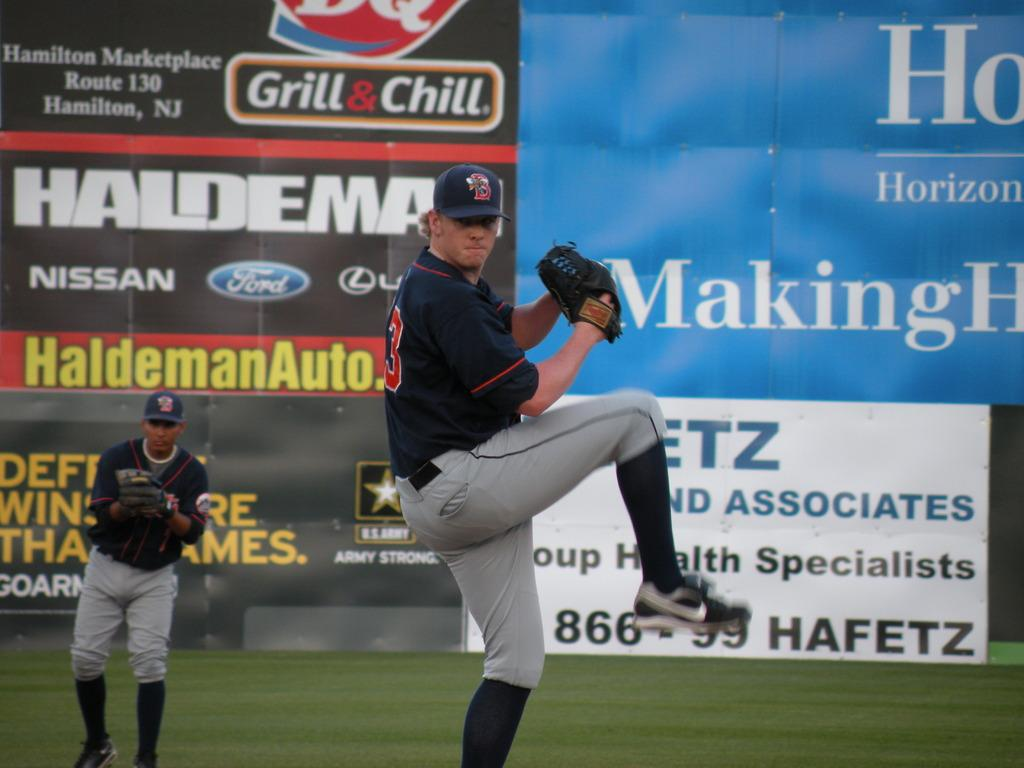<image>
Share a concise interpretation of the image provided. the word Making is on the ad in the outfie;d 